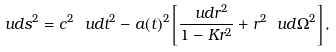Convert formula to latex. <formula><loc_0><loc_0><loc_500><loc_500>\ u d s ^ { 2 } = c ^ { 2 } \ u d t ^ { 2 } - a ( t ) ^ { 2 } \left [ \frac { \ u d r ^ { 2 } } { 1 - K r ^ { 2 } } + r ^ { 2 } \ u d \Omega ^ { 2 } \right ] ,</formula> 